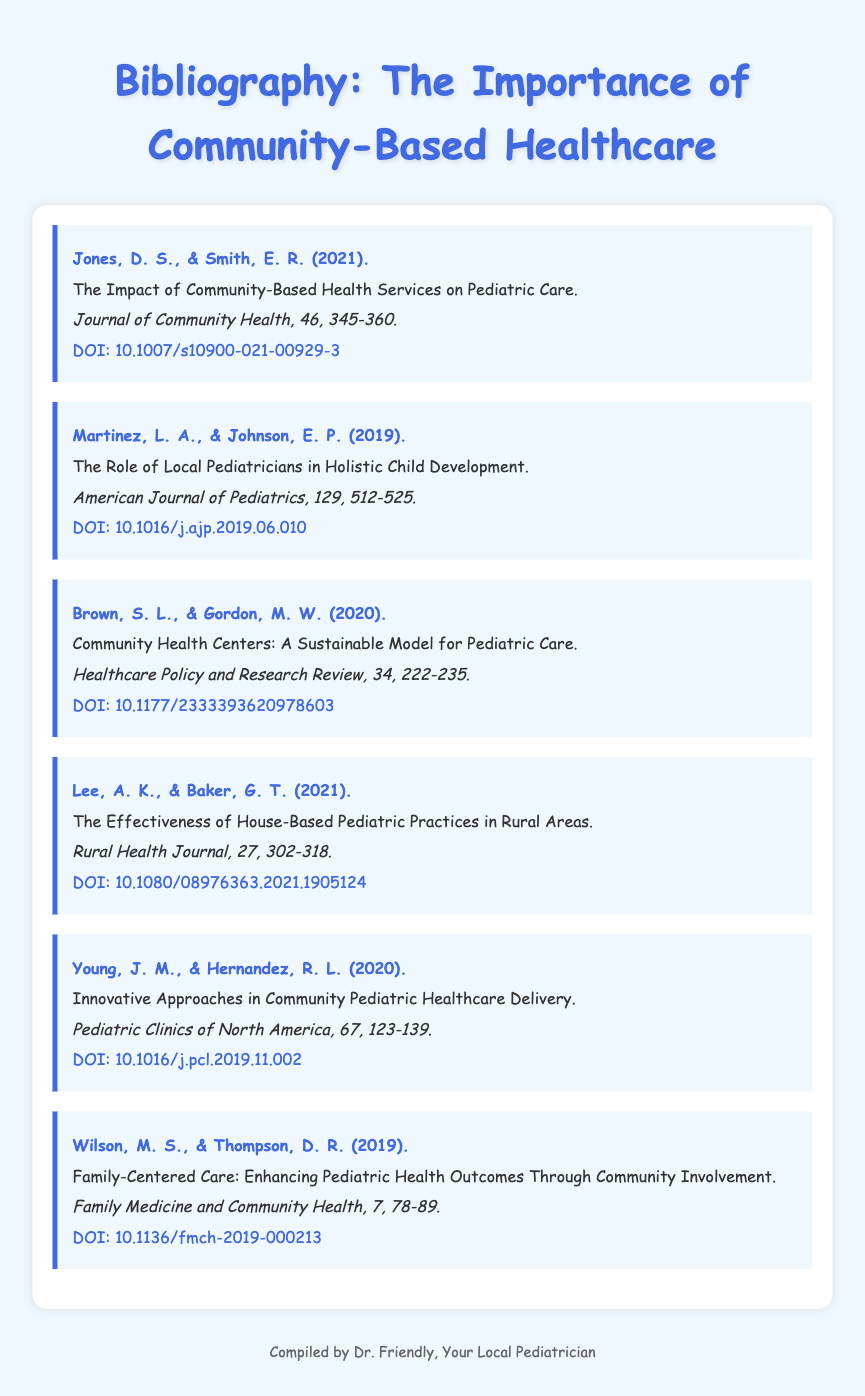What is the title of the first entry? The title of the first entry can be found directly under the authors' names in the document.
Answer: The Impact of Community-Based Health Services on Pediatric Care Who are the authors of the second entry? The authors’ names are provided at the beginning of each entry.
Answer: Martinez, L. A., & Johnson, E. P In which journal was the article "Community Health Centers: A Sustainable Model for Pediatric Care" published? The journal name appears italicized in each entry following the title.
Answer: Healthcare Policy and Research Review What year was the article "Innovative Approaches in Community Pediatric Healthcare Delivery" published? The year of publication is included in parentheses right after the authors' names.
Answer: 2020 How many articles are referenced in the bibliography? The number of articles can be counted by looking at the entries in the document.
Answer: Six What is the DOI of the last entry? The DOI is listed after the journal citation for each entry and provides a direct link to the article.
Answer: 10.1136/fmch-2019-000213 Which entry focuses on the effectiveness of house-based practices? The focus of each entry is indicated in the title, which describes the main topic of the article.
Answer: The Effectiveness of House-Based Pediatric Practices in Rural Areas Which authors contributed to the journal article regarding family-centered care? The authors' names are listed at the beginning of the entry about family-centered care.
Answer: Wilson, M. S., & Thompson, D. R 